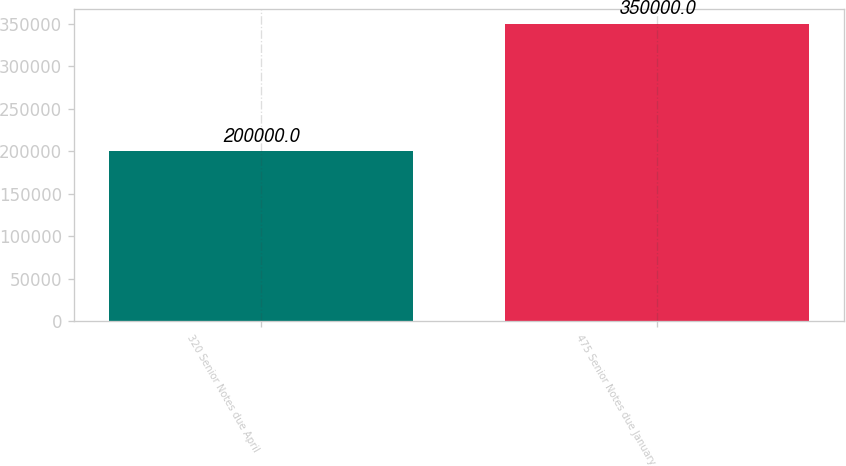Convert chart to OTSL. <chart><loc_0><loc_0><loc_500><loc_500><bar_chart><fcel>320 Senior Notes due April<fcel>475 Senior Notes due January<nl><fcel>200000<fcel>350000<nl></chart> 